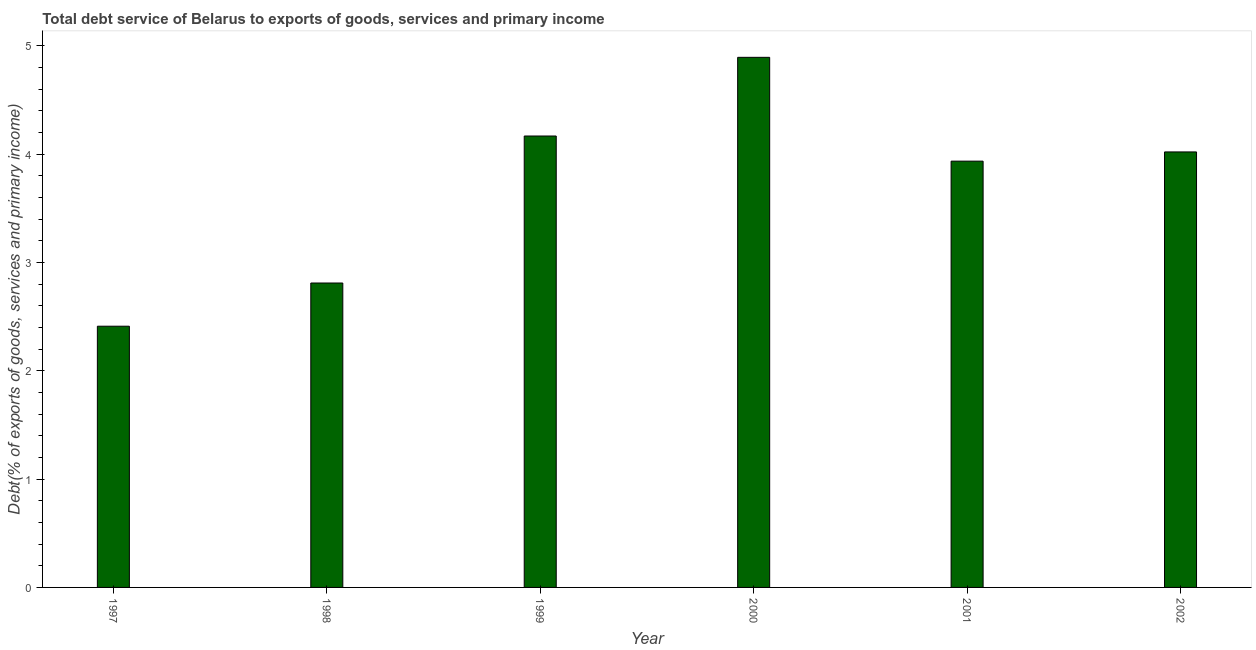Does the graph contain any zero values?
Your response must be concise. No. Does the graph contain grids?
Make the answer very short. No. What is the title of the graph?
Your answer should be compact. Total debt service of Belarus to exports of goods, services and primary income. What is the label or title of the X-axis?
Give a very brief answer. Year. What is the label or title of the Y-axis?
Your answer should be very brief. Debt(% of exports of goods, services and primary income). What is the total debt service in 1997?
Your answer should be very brief. 2.41. Across all years, what is the maximum total debt service?
Give a very brief answer. 4.89. Across all years, what is the minimum total debt service?
Your answer should be very brief. 2.41. What is the sum of the total debt service?
Give a very brief answer. 22.23. What is the difference between the total debt service in 1998 and 2000?
Your answer should be very brief. -2.08. What is the average total debt service per year?
Provide a succinct answer. 3.71. What is the median total debt service?
Your answer should be compact. 3.98. What is the ratio of the total debt service in 2000 to that in 2002?
Give a very brief answer. 1.22. Is the total debt service in 1999 less than that in 2001?
Offer a very short reply. No. Is the difference between the total debt service in 1997 and 2002 greater than the difference between any two years?
Your response must be concise. No. What is the difference between the highest and the second highest total debt service?
Your answer should be very brief. 0.73. Is the sum of the total debt service in 1998 and 2002 greater than the maximum total debt service across all years?
Offer a very short reply. Yes. What is the difference between the highest and the lowest total debt service?
Your answer should be very brief. 2.48. How many bars are there?
Give a very brief answer. 6. Are all the bars in the graph horizontal?
Your answer should be compact. No. How many years are there in the graph?
Offer a very short reply. 6. What is the Debt(% of exports of goods, services and primary income) of 1997?
Give a very brief answer. 2.41. What is the Debt(% of exports of goods, services and primary income) of 1998?
Provide a succinct answer. 2.81. What is the Debt(% of exports of goods, services and primary income) in 1999?
Your answer should be compact. 4.17. What is the Debt(% of exports of goods, services and primary income) of 2000?
Your answer should be very brief. 4.89. What is the Debt(% of exports of goods, services and primary income) in 2001?
Make the answer very short. 3.93. What is the Debt(% of exports of goods, services and primary income) in 2002?
Offer a very short reply. 4.02. What is the difference between the Debt(% of exports of goods, services and primary income) in 1997 and 1998?
Your response must be concise. -0.4. What is the difference between the Debt(% of exports of goods, services and primary income) in 1997 and 1999?
Make the answer very short. -1.76. What is the difference between the Debt(% of exports of goods, services and primary income) in 1997 and 2000?
Keep it short and to the point. -2.48. What is the difference between the Debt(% of exports of goods, services and primary income) in 1997 and 2001?
Make the answer very short. -1.52. What is the difference between the Debt(% of exports of goods, services and primary income) in 1997 and 2002?
Make the answer very short. -1.61. What is the difference between the Debt(% of exports of goods, services and primary income) in 1998 and 1999?
Offer a terse response. -1.36. What is the difference between the Debt(% of exports of goods, services and primary income) in 1998 and 2000?
Keep it short and to the point. -2.08. What is the difference between the Debt(% of exports of goods, services and primary income) in 1998 and 2001?
Your answer should be compact. -1.12. What is the difference between the Debt(% of exports of goods, services and primary income) in 1998 and 2002?
Provide a succinct answer. -1.21. What is the difference between the Debt(% of exports of goods, services and primary income) in 1999 and 2000?
Keep it short and to the point. -0.73. What is the difference between the Debt(% of exports of goods, services and primary income) in 1999 and 2001?
Your answer should be very brief. 0.23. What is the difference between the Debt(% of exports of goods, services and primary income) in 1999 and 2002?
Your answer should be compact. 0.15. What is the difference between the Debt(% of exports of goods, services and primary income) in 2000 and 2001?
Your answer should be compact. 0.96. What is the difference between the Debt(% of exports of goods, services and primary income) in 2000 and 2002?
Ensure brevity in your answer.  0.87. What is the difference between the Debt(% of exports of goods, services and primary income) in 2001 and 2002?
Provide a succinct answer. -0.09. What is the ratio of the Debt(% of exports of goods, services and primary income) in 1997 to that in 1998?
Provide a succinct answer. 0.86. What is the ratio of the Debt(% of exports of goods, services and primary income) in 1997 to that in 1999?
Your answer should be very brief. 0.58. What is the ratio of the Debt(% of exports of goods, services and primary income) in 1997 to that in 2000?
Offer a terse response. 0.49. What is the ratio of the Debt(% of exports of goods, services and primary income) in 1997 to that in 2001?
Your answer should be compact. 0.61. What is the ratio of the Debt(% of exports of goods, services and primary income) in 1997 to that in 2002?
Keep it short and to the point. 0.6. What is the ratio of the Debt(% of exports of goods, services and primary income) in 1998 to that in 1999?
Your answer should be very brief. 0.67. What is the ratio of the Debt(% of exports of goods, services and primary income) in 1998 to that in 2000?
Your response must be concise. 0.57. What is the ratio of the Debt(% of exports of goods, services and primary income) in 1998 to that in 2001?
Offer a terse response. 0.71. What is the ratio of the Debt(% of exports of goods, services and primary income) in 1998 to that in 2002?
Offer a terse response. 0.7. What is the ratio of the Debt(% of exports of goods, services and primary income) in 1999 to that in 2000?
Offer a terse response. 0.85. What is the ratio of the Debt(% of exports of goods, services and primary income) in 1999 to that in 2001?
Your answer should be very brief. 1.06. What is the ratio of the Debt(% of exports of goods, services and primary income) in 2000 to that in 2001?
Your response must be concise. 1.24. What is the ratio of the Debt(% of exports of goods, services and primary income) in 2000 to that in 2002?
Your answer should be compact. 1.22. What is the ratio of the Debt(% of exports of goods, services and primary income) in 2001 to that in 2002?
Keep it short and to the point. 0.98. 